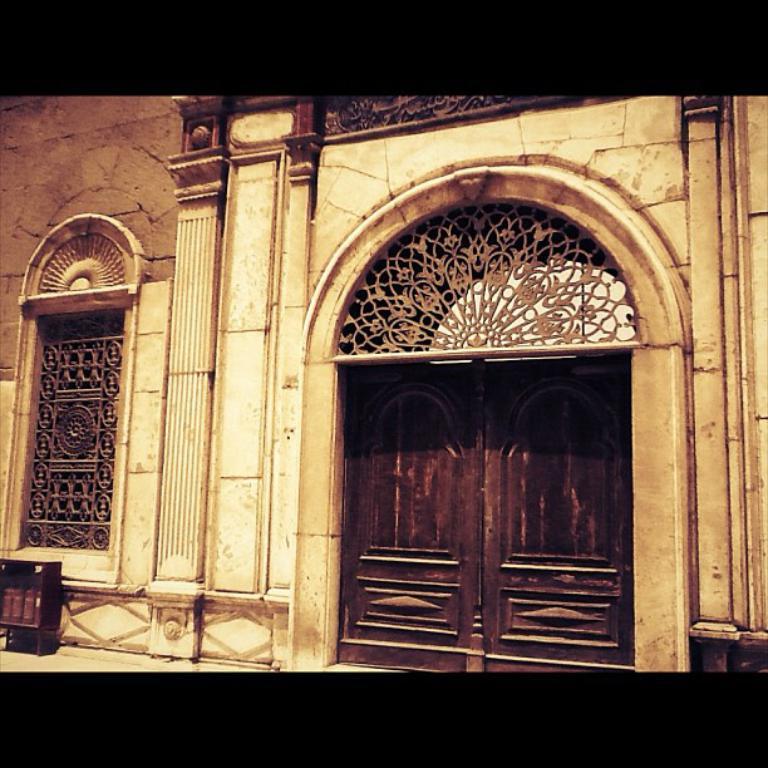Describe this image in one or two sentences. In the image we can see a wall, door, window and this is a fence design. 